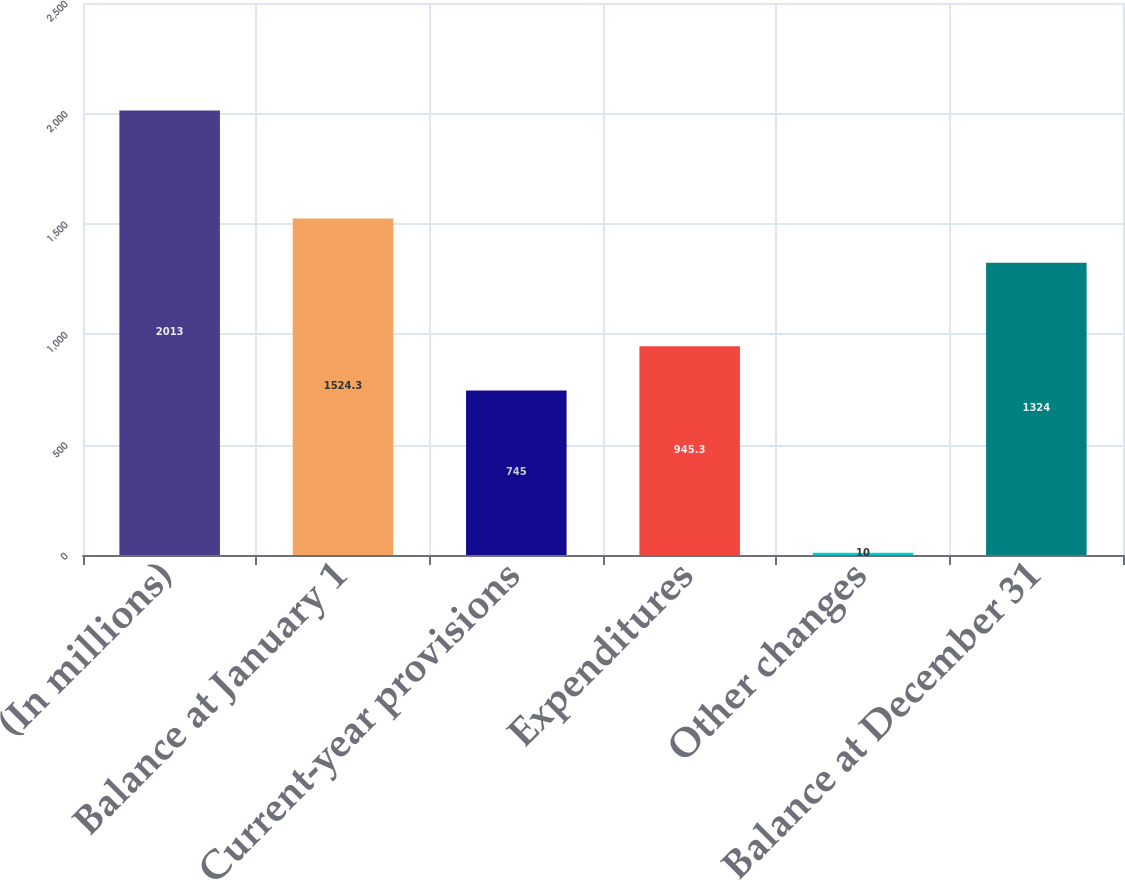Convert chart. <chart><loc_0><loc_0><loc_500><loc_500><bar_chart><fcel>(In millions)<fcel>Balance at January 1<fcel>Current-year provisions<fcel>Expenditures<fcel>Other changes<fcel>Balance at December 31<nl><fcel>2013<fcel>1524.3<fcel>745<fcel>945.3<fcel>10<fcel>1324<nl></chart> 